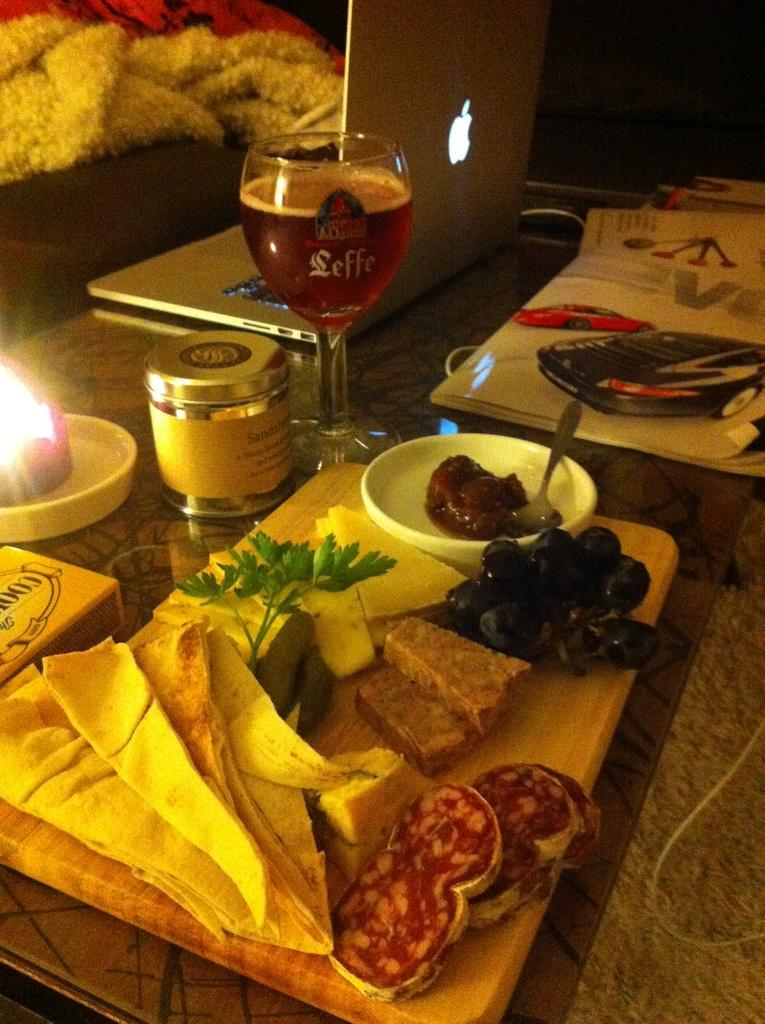What is the main object in the center of the image? There is a table in the center of the image. What can be found on the table? There are food items, a wine glass, a laptop, a book, and other objects on the table. Can you describe the food items on the table? The food items on the table are not specified in the facts provided. What type of glass is on the table? There is a wine glass on the table. Is the water in the image boiling hot? There is no water present in the image, so it cannot be determined if it is boiling hot or not. 